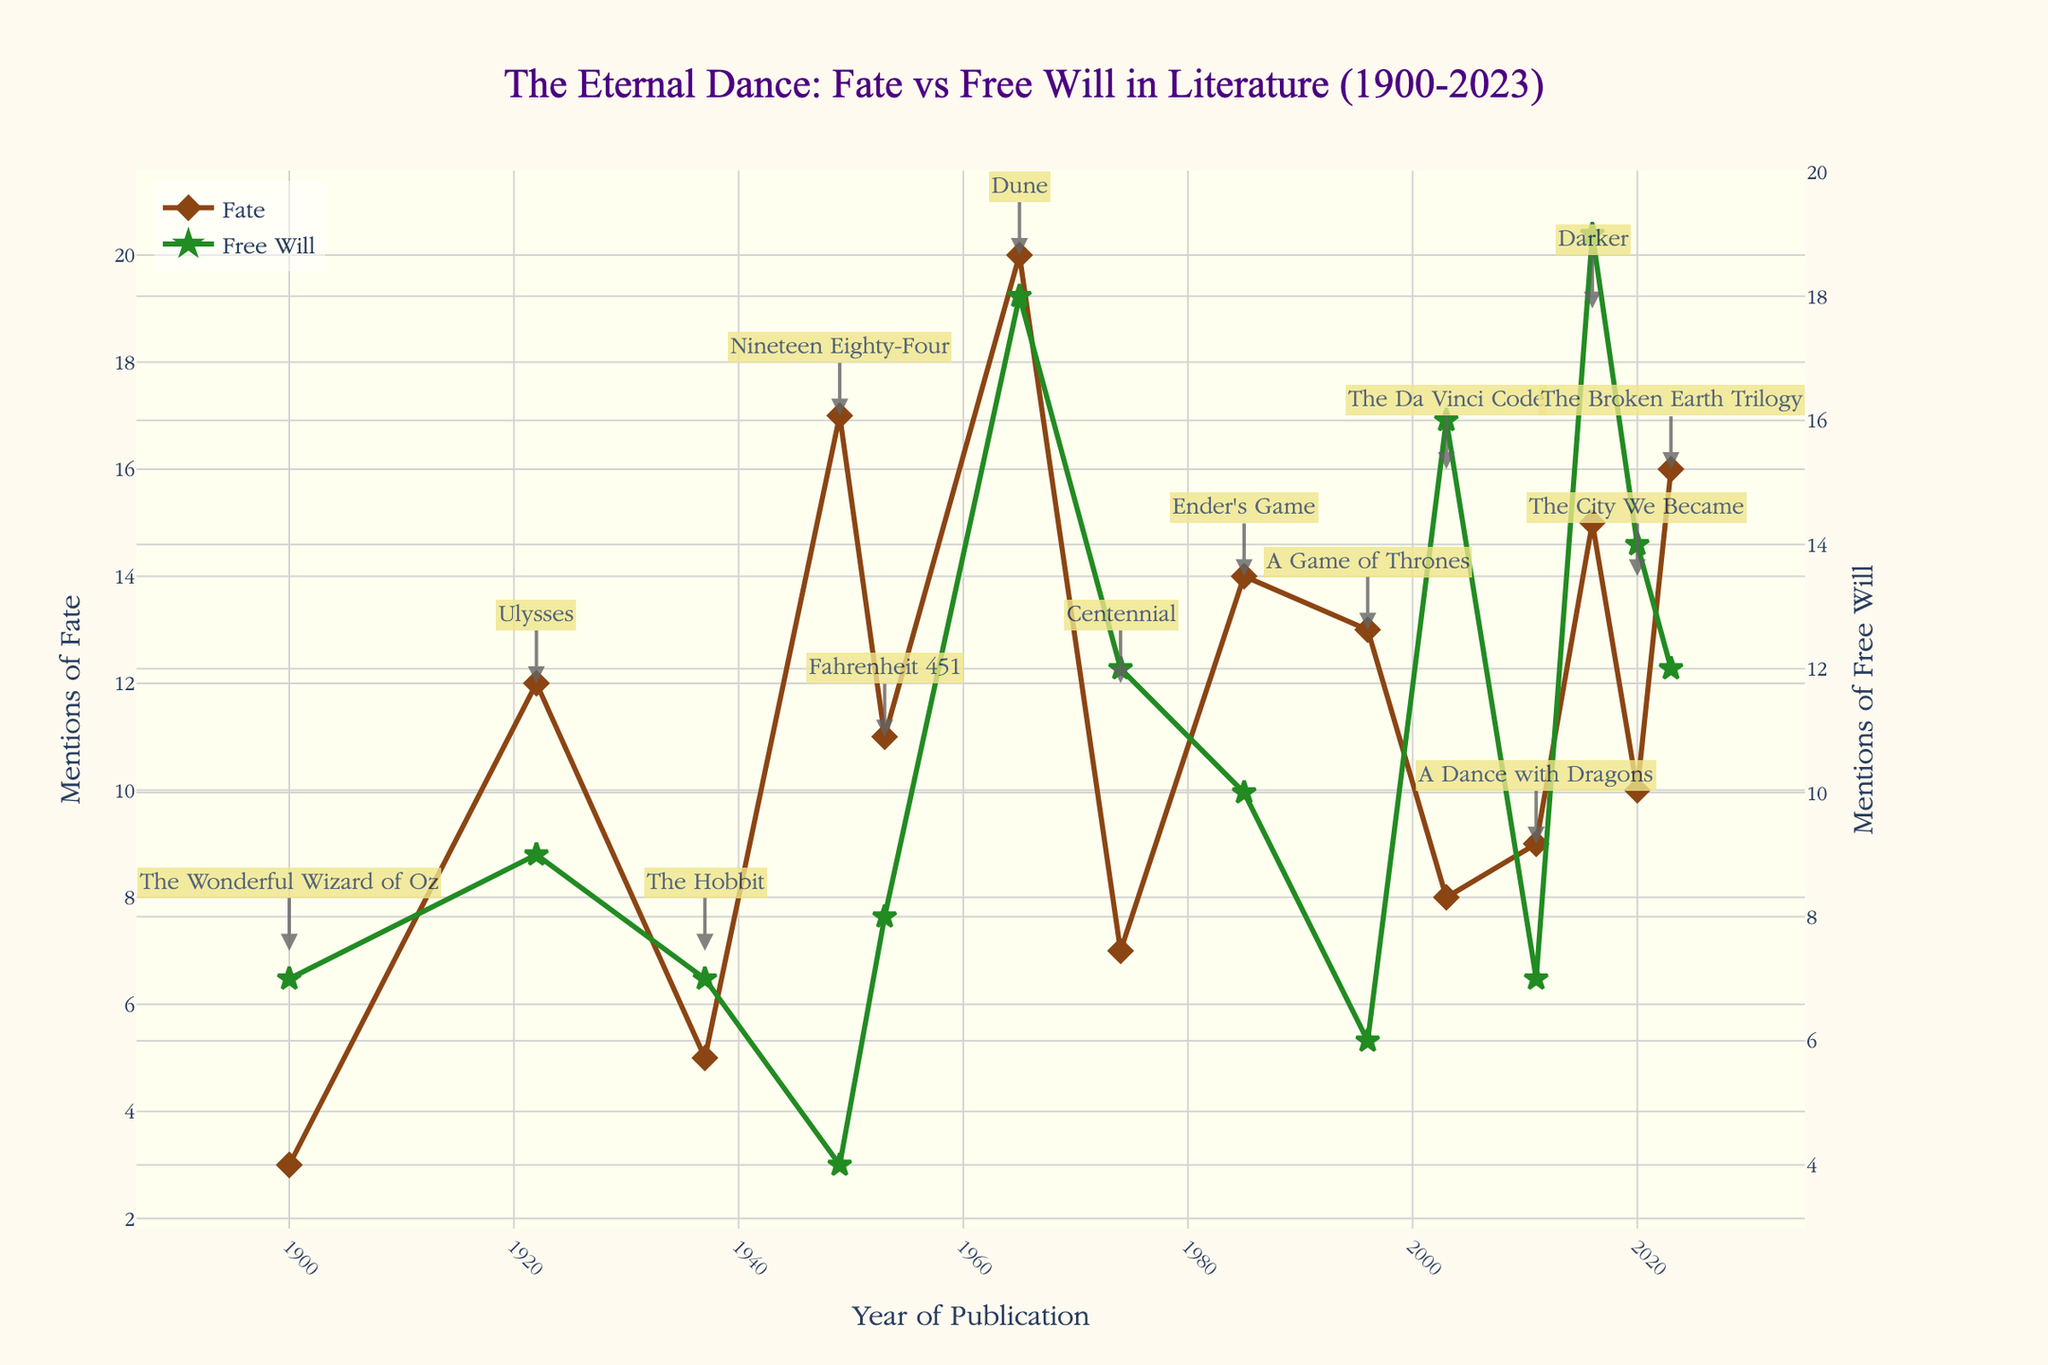Which year had the highest mentions of Fate? To find this, look at the peak in the "Mentions of Fate" line (brown color) and refer to the annotation text for the specific year. The highest point is alongside 1965 with the book "Dune" by Frank Herbert.
Answer: 1965 Which book has the highest mentions of Free Will? Examine the peaks in the "Mentions of Free Will" line (green color). The highest point is annotated with Marlon James' book "Darker" in 2016.
Answer: Darker How many books have more mentions of Fate than Free Will? Count the instances where the brown line (Fate) is higher than the green line (Free Will). These occur in 1922, 1937, 1949, 1953, 1965, 1985, 1996, 2023.
Answer: 8 What is the trend for Mentions of Free Will from 2000 onwards? Inspect the green line from 2000 onwards. The mentions initially rise steeply from 2003 to 2016 and then show a slight decline by 2023.
Answer: Rising then slightly declining When did the mentions of Fate and Free Will converge closest to each other? Find the point where the brown and green lines are closest. This convergence appears around 1965 with Frank Herbert's "Dune," where mentions of Fate (20) and Free Will (18) are very close.
Answer: 1965 Compare the number of mentions of Fate between "The Hobbit" and "Nineteen Eighty-Four." Note the mentions of Fate for each book using the annotations: "The Hobbit" has 5, while "Nineteen Eighty-Four" has 17.
Answer: 5 for The Hobbit and 17 for Nineteen Eighty-Four What are the average mentions of Fate and Free Will across the dataset? Sum the mentions of Fate and Free Will and divide by the number of books (13). Sum for Fate is (3+12+5+17+11+20+7+14+13+8+9+15+10+16) = 160. Sum for Free Will is (7+9+7+4+8+18+12+10+6+16+7+19+14+12) = 143. Averages are 160/13, 143/13 respectively.
Answer: 12.31 for Fate, 11 for Free Will How does J.R.R. Tolkien's "The Hobbit" compare in mentions of Fate and Free Will to George R.R. Martin's "A Game of Thrones"? Check the annotations: "The Hobbit" has 5 mentions of Fate and 7 of Free Will. "A Game of Thrones" has 13 mentions of Fate and 6 of Free Will.
Answer: The Hobbit: 5 Fate, 7 Free Will; A Game of Thrones: 13 Fate, 6 Free Will Which author mentioned Free Will the most in their works? Look at the annotations with the highest peak for Free Will mentions: Marlon James in "Darker" in 2016 with 19 mentions.
Answer: Marlon James 